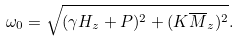Convert formula to latex. <formula><loc_0><loc_0><loc_500><loc_500>\omega _ { 0 } = \sqrt { ( \gamma H _ { z } + P ) ^ { 2 } + ( K \overline { M } _ { z } ) ^ { 2 } } .</formula> 